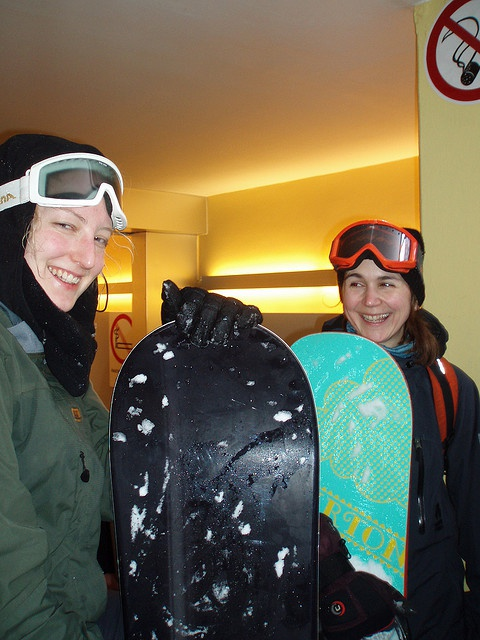Describe the objects in this image and their specific colors. I can see snowboard in gray, black, and blue tones, surfboard in gray, black, and blue tones, people in gray, black, teal, and pink tones, people in gray, black, maroon, and darkgray tones, and snowboard in gray, turquoise, and lightblue tones in this image. 